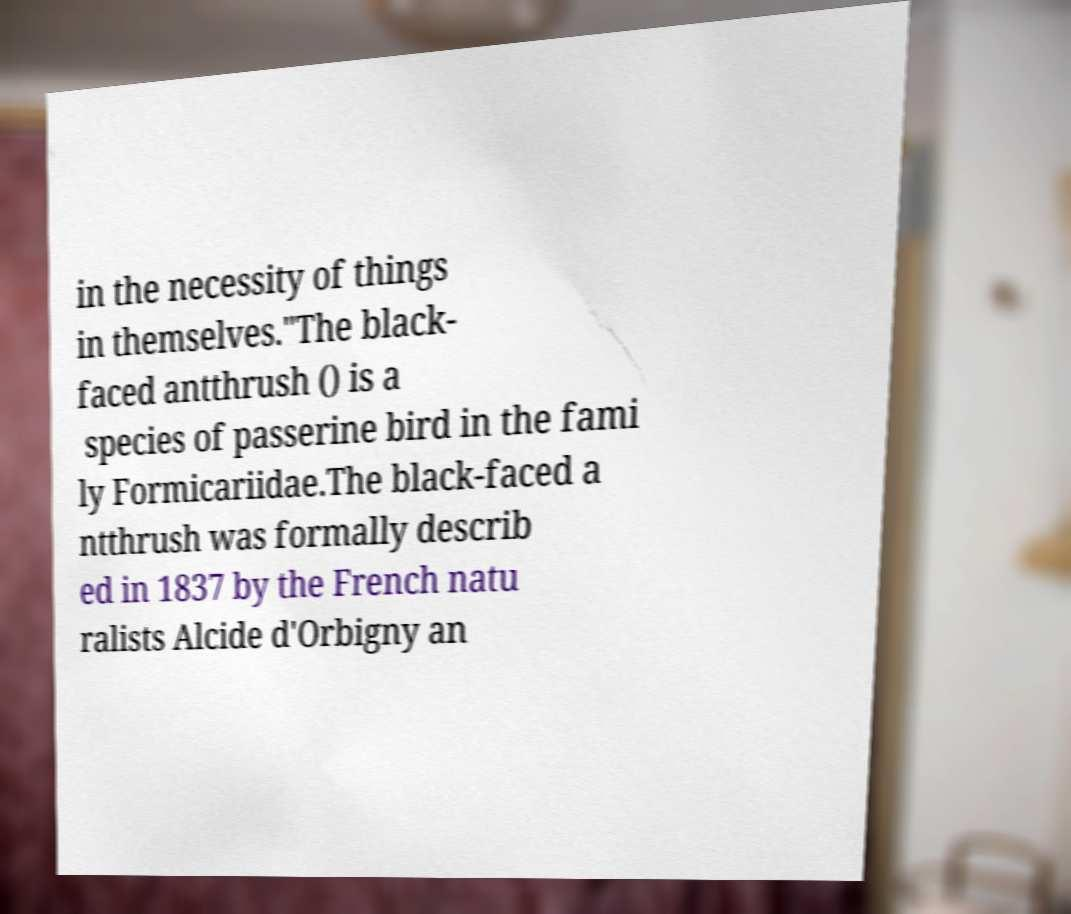Please identify and transcribe the text found in this image. in the necessity of things in themselves."The black- faced antthrush () is a species of passerine bird in the fami ly Formicariidae.The black-faced a ntthrush was formally describ ed in 1837 by the French natu ralists Alcide d'Orbigny an 